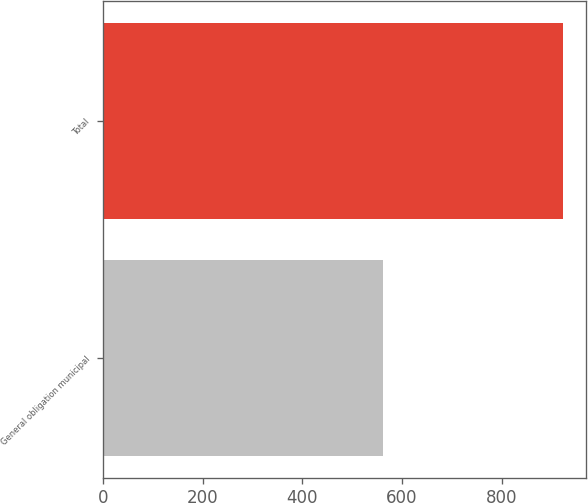Convert chart to OTSL. <chart><loc_0><loc_0><loc_500><loc_500><bar_chart><fcel>General obligation municipal<fcel>Total<nl><fcel>561.4<fcel>923<nl></chart> 